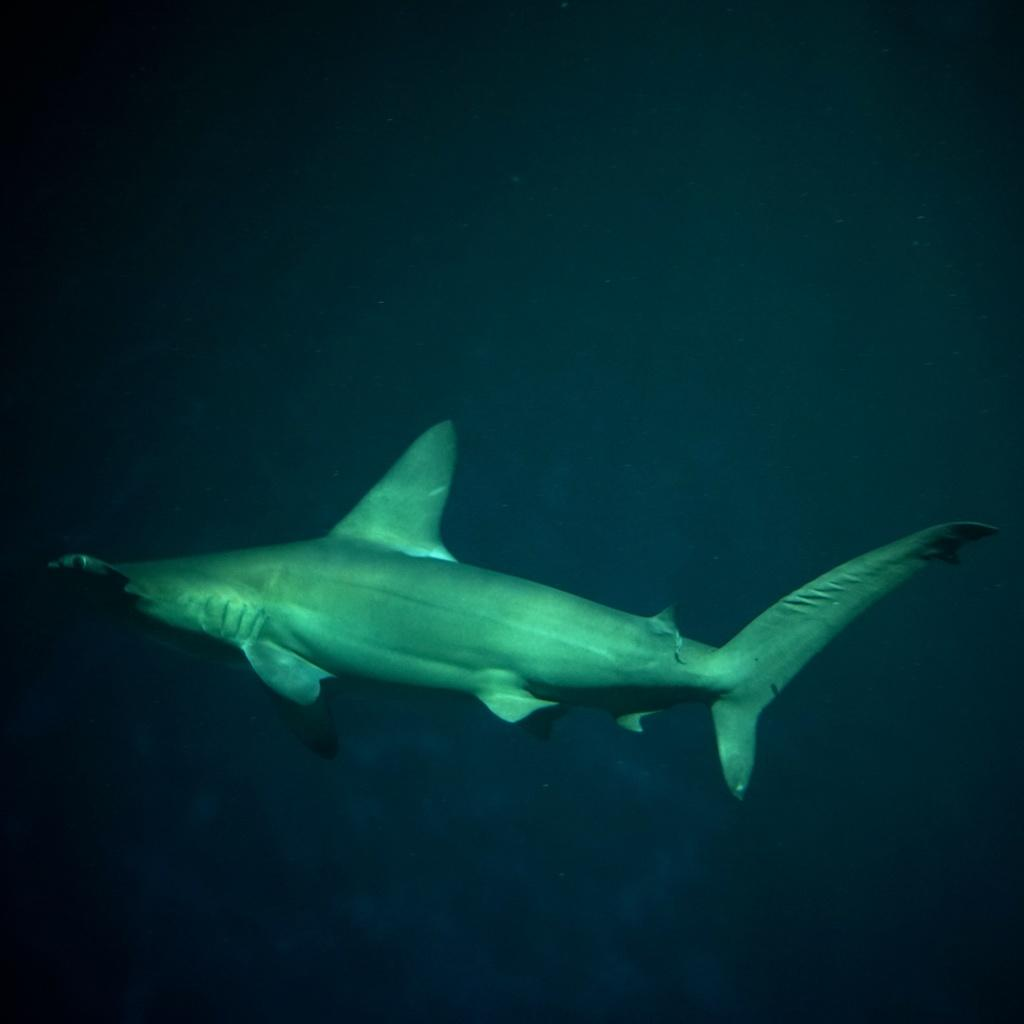What is the focus of the image? The image is zoomed in on a fish. Can you describe the fish in the image? The fish is in the center of the image and appears to be swimming in the water. What type of feather can be seen floating near the fish in the image? There is no feather present in the image; it features a fish swimming in the water. How many quinces are visible in the image? There are no quinces present in the image. 